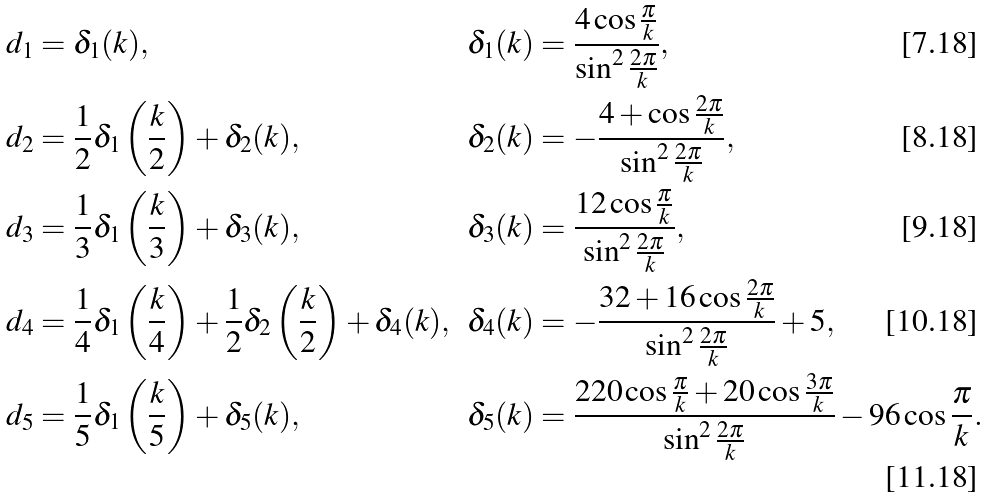<formula> <loc_0><loc_0><loc_500><loc_500>d _ { 1 } & = \delta _ { 1 } ( k ) , & \delta _ { 1 } ( k ) & = \frac { 4 \cos \frac { \pi } { k } } { \sin ^ { 2 } \frac { 2 \pi } { k } } , \\ d _ { 2 } & = \frac { 1 } { 2 } \delta _ { 1 } \left ( \frac { k } { 2 } \right ) + \delta _ { 2 } ( k ) , & \delta _ { 2 } ( k ) & = - \frac { 4 + \cos \frac { 2 \pi } { k } } { \sin ^ { 2 } \frac { 2 \pi } { k } } , \\ d _ { 3 } & = \frac { 1 } { 3 } \delta _ { 1 } \left ( \frac { k } { 3 } \right ) + \delta _ { 3 } ( k ) , & \delta _ { 3 } ( k ) & = \frac { 1 2 \cos \frac { \pi } { k } } { \sin ^ { 2 } \frac { 2 \pi } { k } } , \\ d _ { 4 } & = \frac { 1 } { 4 } \delta _ { 1 } \left ( \frac { k } { 4 } \right ) + \frac { 1 } { 2 } \delta _ { 2 } \left ( \frac { k } { 2 } \right ) + \delta _ { 4 } ( k ) , & \delta _ { 4 } ( k ) & = - \frac { 3 2 + 1 6 \cos \frac { 2 \pi } { k } } { \sin ^ { 2 } \frac { 2 \pi } { k } } + 5 , \\ d _ { 5 } & = \frac { 1 } { 5 } \delta _ { 1 } \left ( \frac { k } { 5 } \right ) + \delta _ { 5 } ( k ) , & \delta _ { 5 } ( k ) & = \frac { 2 2 0 \cos \frac { \pi } { k } + 2 0 \cos \frac { 3 \pi } { k } } { \sin ^ { 2 } \frac { 2 \pi } { k } } - 9 6 \cos \frac { \pi } { k } .</formula> 